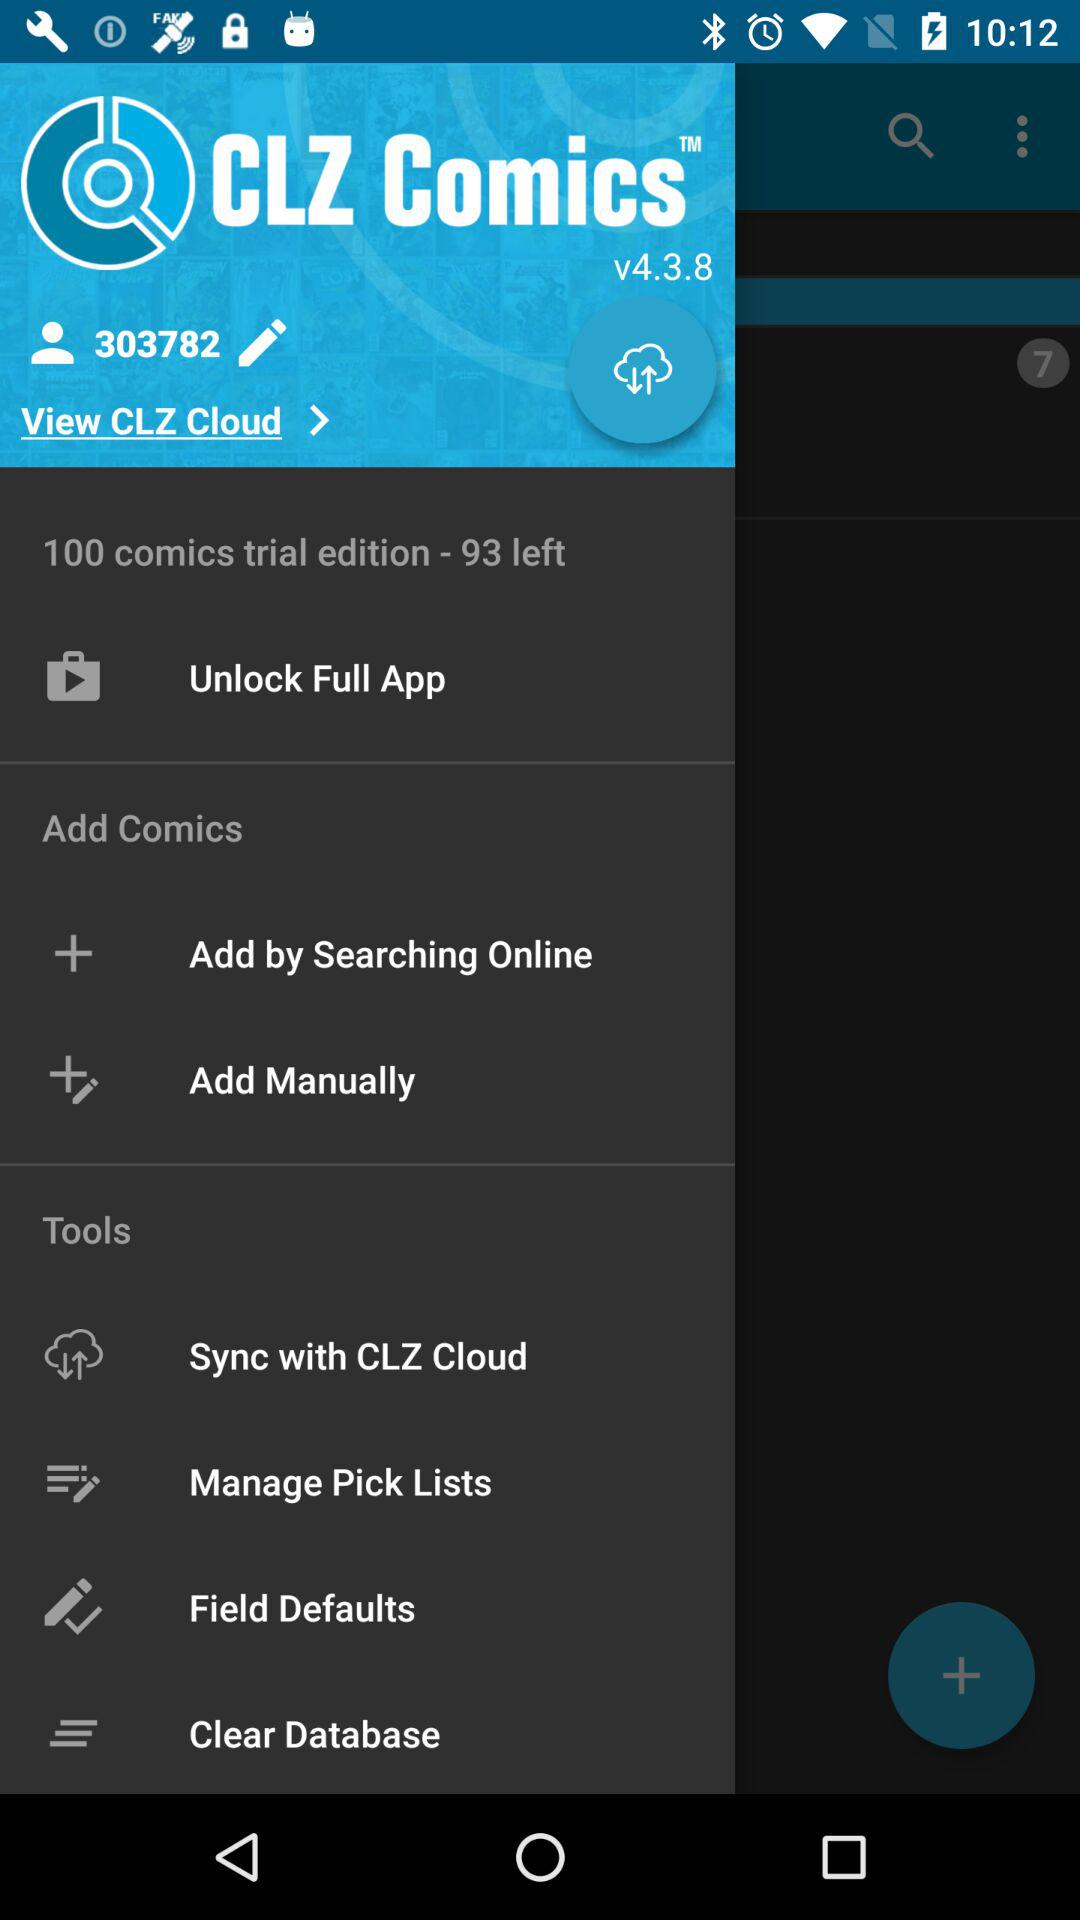What is the name of the application? The name of the application is "CLZ Comics". 